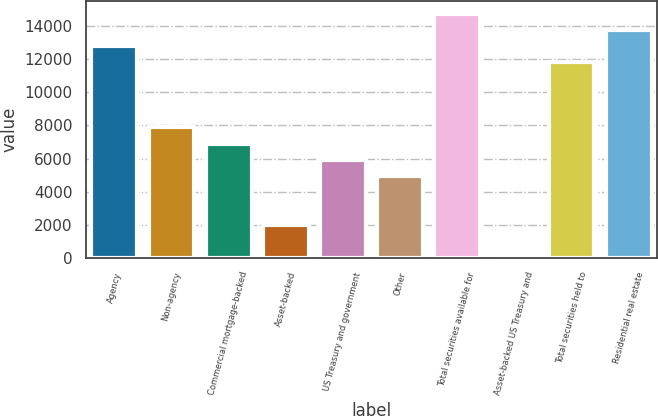Convert chart. <chart><loc_0><loc_0><loc_500><loc_500><bar_chart><fcel>Agency<fcel>Non-agency<fcel>Commercial mortgage-backed<fcel>Asset-backed<fcel>US Treasury and government<fcel>Other<fcel>Total securities available for<fcel>Asset-backed US Treasury and<fcel>Total securities held to<fcel>Residential real estate<nl><fcel>12796.9<fcel>7880.4<fcel>6897.1<fcel>1980.6<fcel>5913.8<fcel>4930.5<fcel>14763.5<fcel>14<fcel>11813.6<fcel>13780.2<nl></chart> 